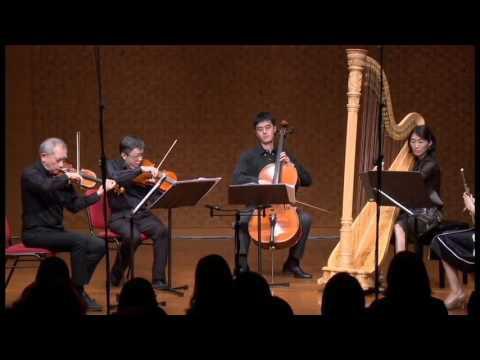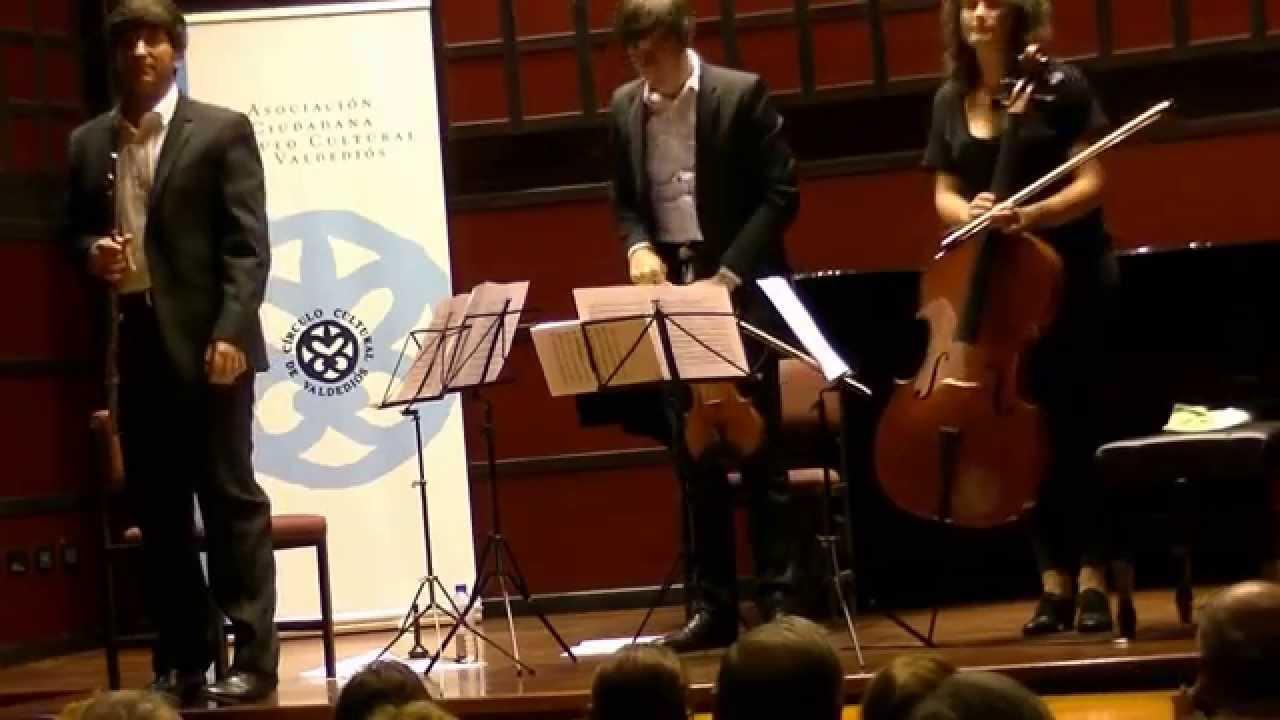The first image is the image on the left, the second image is the image on the right. Assess this claim about the two images: "The image on the left shows a violin player and a flute player sitting side by side.". Correct or not? Answer yes or no. No. The first image is the image on the left, the second image is the image on the right. Considering the images on both sides, is "The image on the left shows an instrumental group with at least four members, and all members sitting on chairs." valid? Answer yes or no. Yes. 